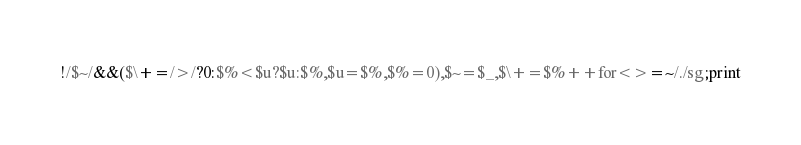Convert code to text. <code><loc_0><loc_0><loc_500><loc_500><_Perl_>!/$~/&&($\+=/>/?0:$%<$u?$u:$%,$u=$%,$%=0),$~=$_,$\+=$%++for<>=~/./sg;print</code> 